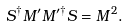<formula> <loc_0><loc_0><loc_500><loc_500>S ^ { \dagger } M ^ { \prime } M ^ { \prime \dagger } S = M ^ { 2 } .</formula> 